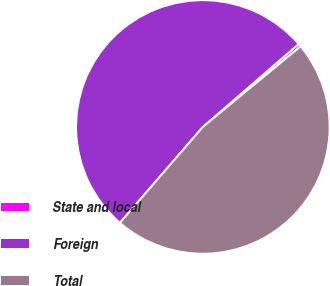Convert chart. <chart><loc_0><loc_0><loc_500><loc_500><pie_chart><fcel>State and local<fcel>Foreign<fcel>Total<nl><fcel>0.39%<fcel>52.29%<fcel>47.32%<nl></chart> 